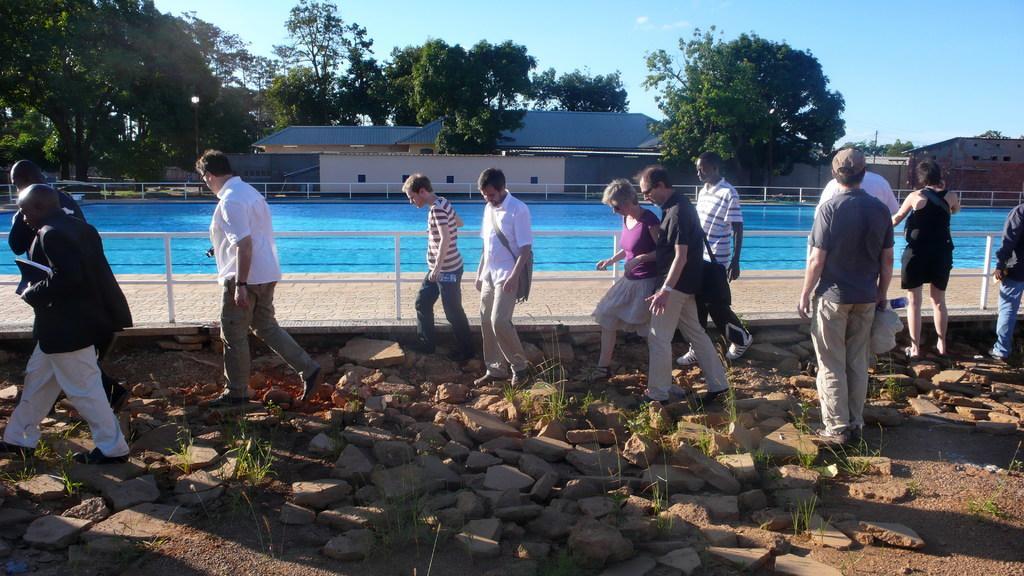Describe this image in one or two sentences. In this image there are people walking on a land, on that land there are stones, in the background there is a pool, houses, trees and the sky. 